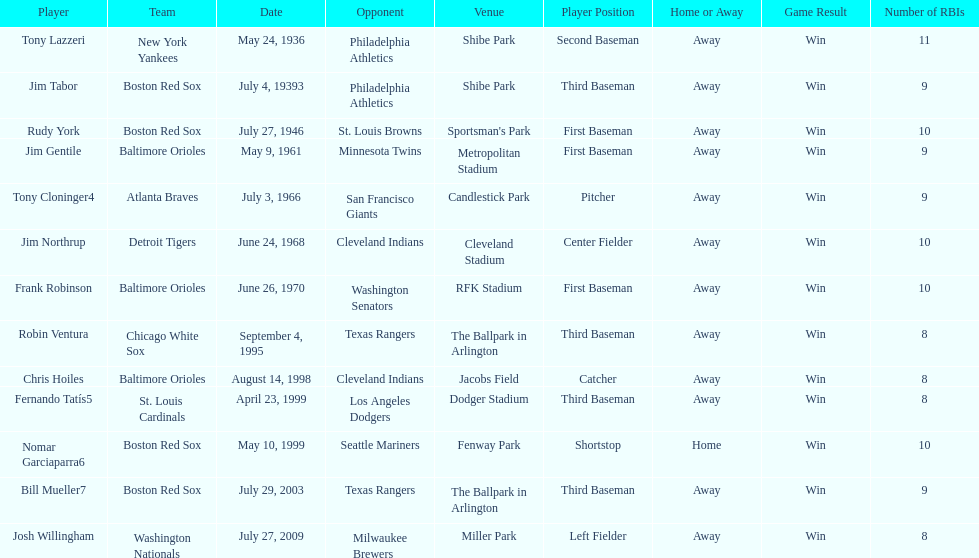What was the name of the last person to accomplish this up to date? Josh Willingham. 